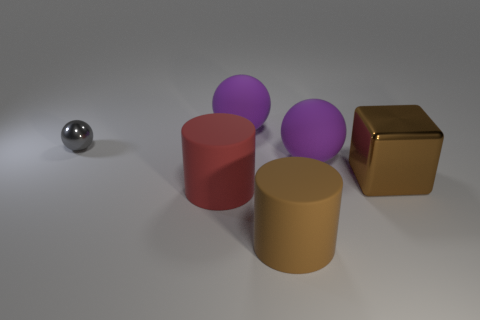What material is the brown cube that is the same size as the red rubber cylinder?
Ensure brevity in your answer.  Metal. The gray sphere to the left of the rubber sphere behind the small shiny object is made of what material?
Make the answer very short. Metal. What number of other objects are there of the same color as the metal block?
Give a very brief answer. 1. There is a metal cube; is it the same color as the large matte cylinder in front of the large red matte thing?
Your answer should be compact. Yes. Is there any other thing that has the same size as the gray sphere?
Offer a terse response. No. There is a cylinder right of the big matte sphere that is behind the gray object; how big is it?
Ensure brevity in your answer.  Large. There is a tiny thing; is it the same shape as the metallic thing in front of the gray metallic object?
Ensure brevity in your answer.  No. What is the shape of the metal object that is right of the red object?
Ensure brevity in your answer.  Cube. Does the brown matte object have the same shape as the red object?
Offer a very short reply. Yes. Is the size of the object that is left of the red cylinder the same as the metallic cube?
Keep it short and to the point. No. 